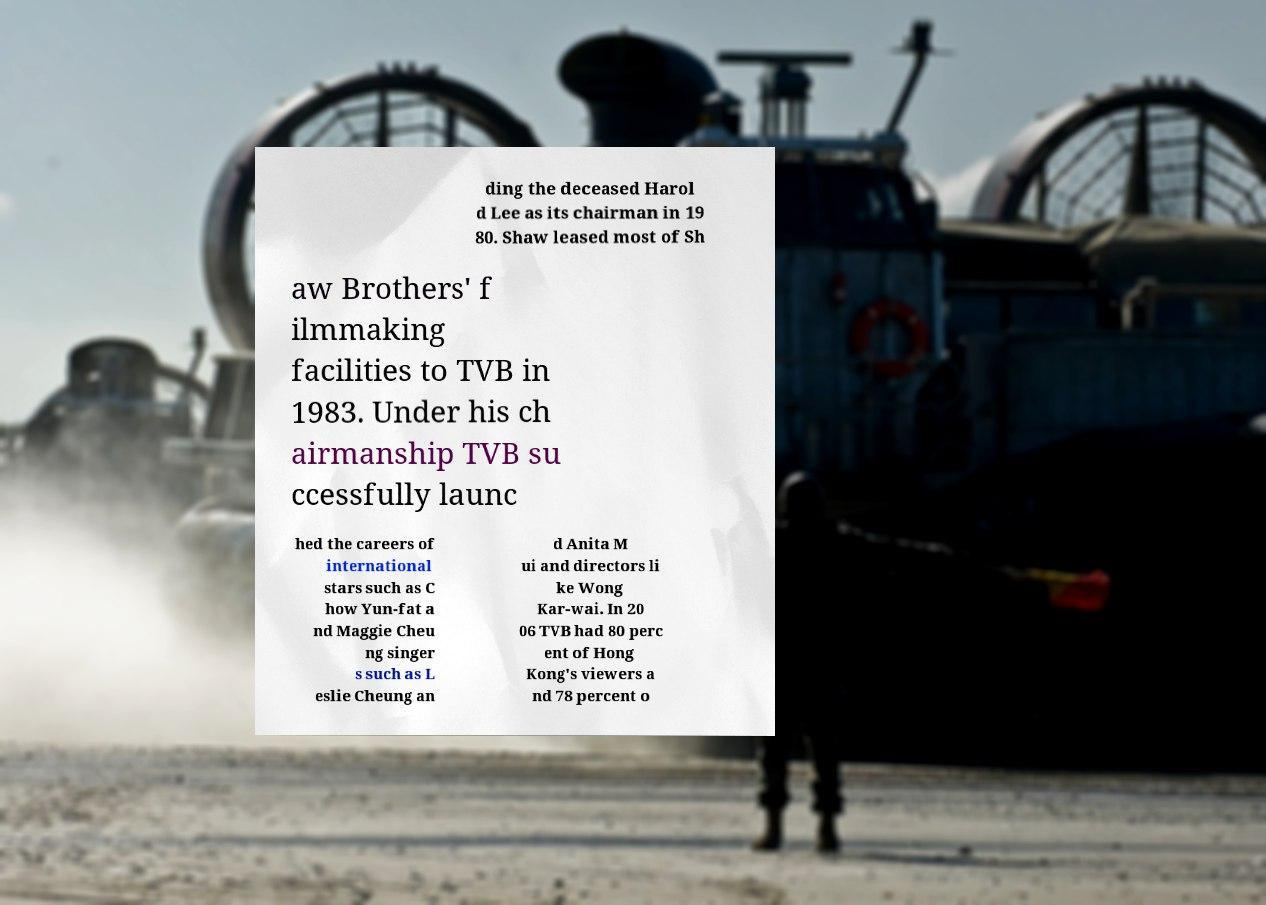Please identify and transcribe the text found in this image. ding the deceased Harol d Lee as its chairman in 19 80. Shaw leased most of Sh aw Brothers' f ilmmaking facilities to TVB in 1983. Under his ch airmanship TVB su ccessfully launc hed the careers of international stars such as C how Yun-fat a nd Maggie Cheu ng singer s such as L eslie Cheung an d Anita M ui and directors li ke Wong Kar-wai. In 20 06 TVB had 80 perc ent of Hong Kong's viewers a nd 78 percent o 